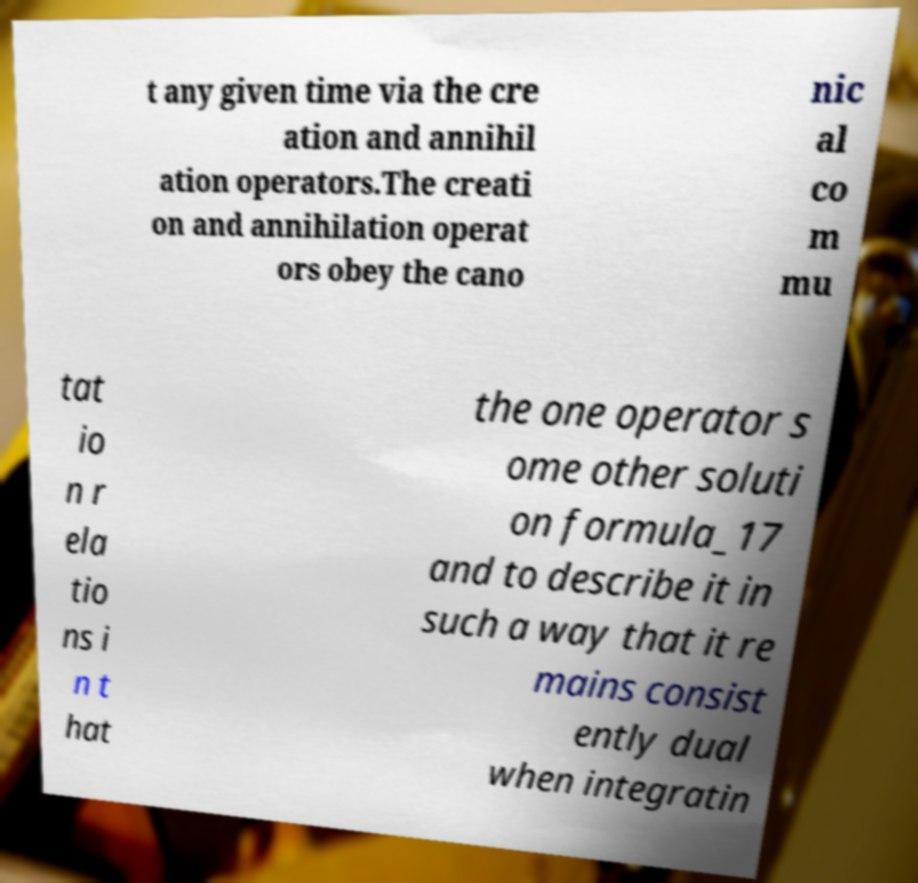Please read and relay the text visible in this image. What does it say? t any given time via the cre ation and annihil ation operators.The creati on and annihilation operat ors obey the cano nic al co m mu tat io n r ela tio ns i n t hat the one operator s ome other soluti on formula_17 and to describe it in such a way that it re mains consist ently dual when integratin 